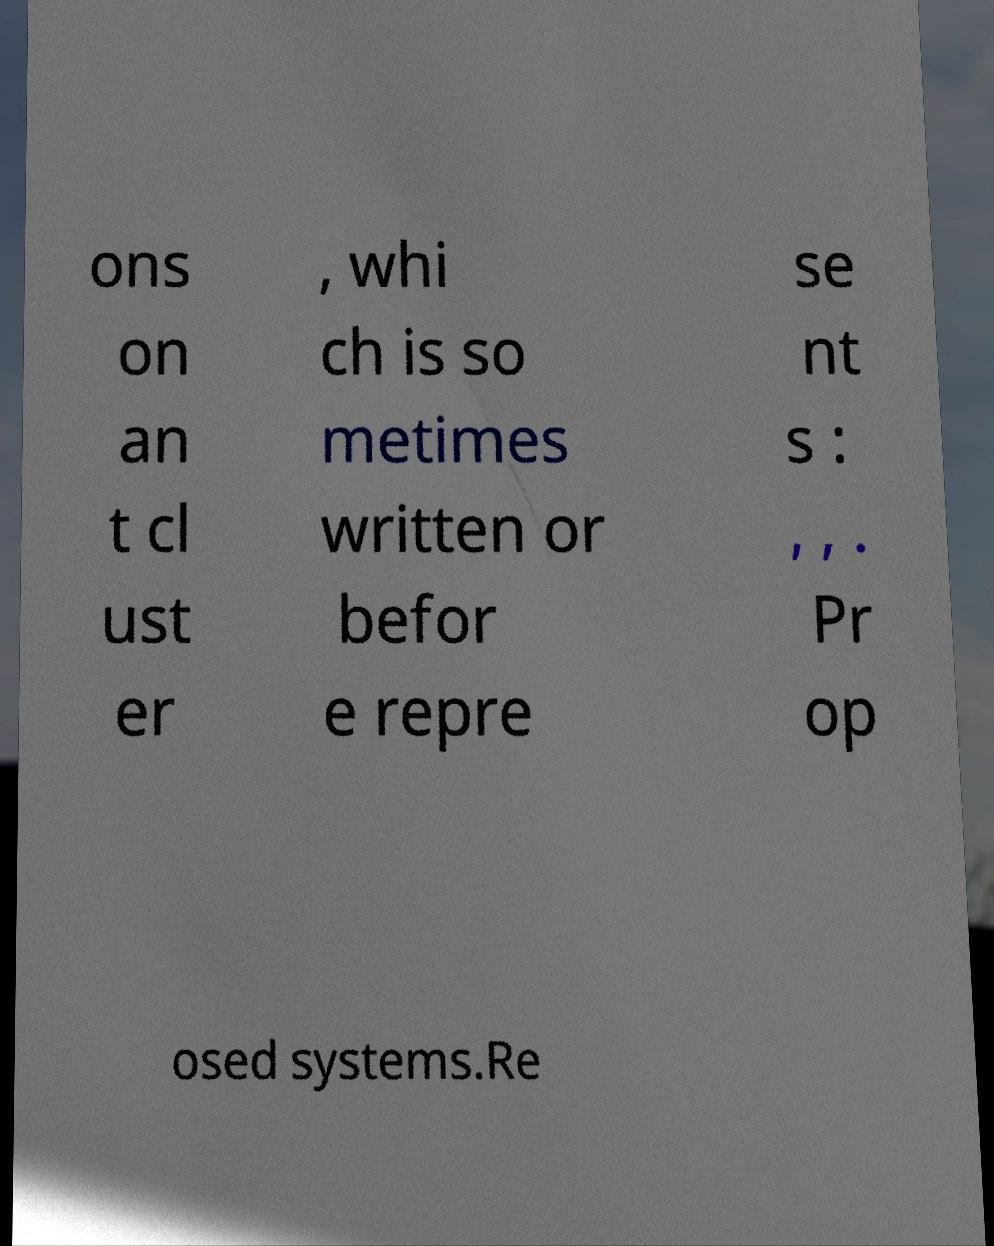There's text embedded in this image that I need extracted. Can you transcribe it verbatim? ons on an t cl ust er , whi ch is so metimes written or befor e repre se nt s : , , . Pr op osed systems.Re 